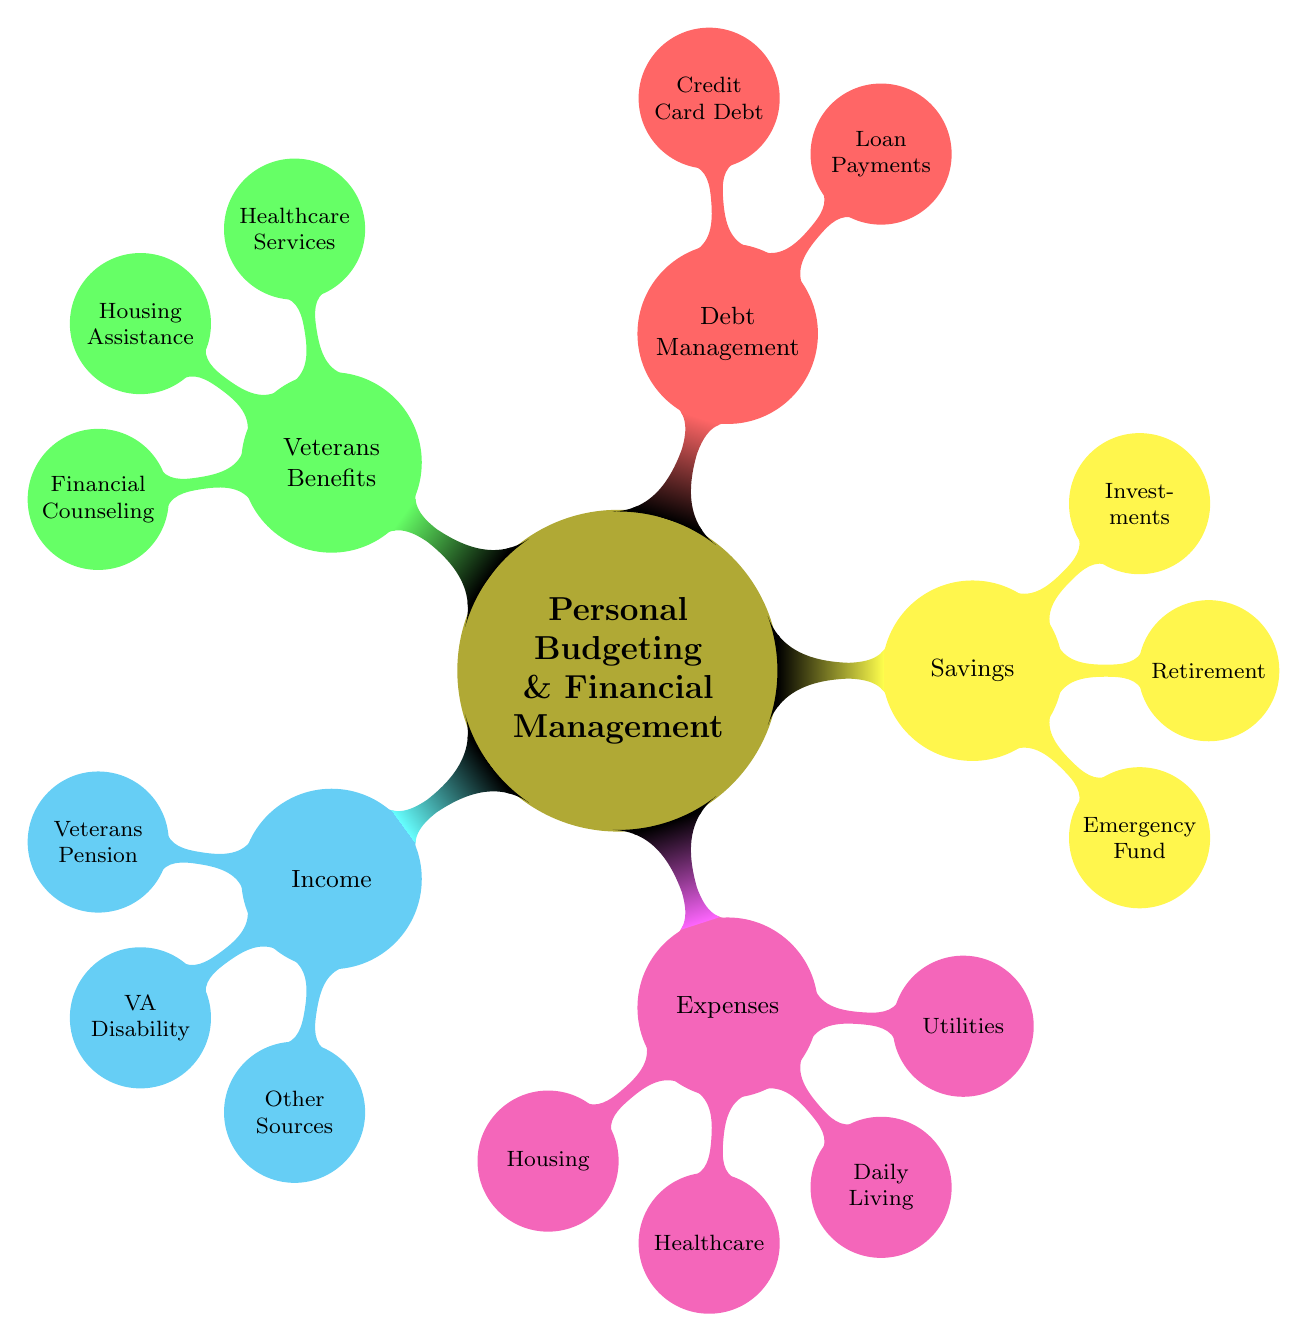What are the main categories in the diagram? The diagram has five main categories: Income, Expenses, Savings, Debt Management, and Veterans Benefits. These categories are represented as the primary branches stemming from the central node.
Answer: Income, Expenses, Savings, Debt Management, Veterans Benefits How many sources are listed under Income? Under the Income category, there are three sources: Veterans Pension, VA Disability, and Other Sources. Counting these gives a total of three sources.
Answer: 3 What types of expenses are included in the diagram? The Expenses category consists of four types: Housing, Healthcare, Daily Living, and Utilities. Each of these expenses is a node under the Expenses branch.
Answer: Housing, Healthcare, Daily Living, Utilities What is the purpose of the Emergency Fund? The Emergency Fund is intended to cover 3-6 months of living expenses. This value indicates the amount set aside for unforeseen circumstances.
Answer: 3-6 months living expenses Which category contains information about VA Medical Centers? The category titled Veterans Benefits contains the information about VA Medical Centers, as it is one of the specific benefits listed under this category.
Answer: Veterans Benefits How many nodes are there under Debt Management? There are two nodes under the Debt Management category: Loan Payments and Credit Card Debt. Therefore, the total number of nodes in this section is two.
Answer: 2 What is the main source of income for veterans? The main source of income for veterans, as indicated in the diagram, is the Veterans Pension Benefit, which is listed under the Income category.
Answer: Veterans Pension Benefit Which type of savings is related to future retirement? The type of savings related to future retirement is the Retirement Savings, specifically indicated by IRA and 401(k) under the Savings category.
Answer: Retirement Savings 